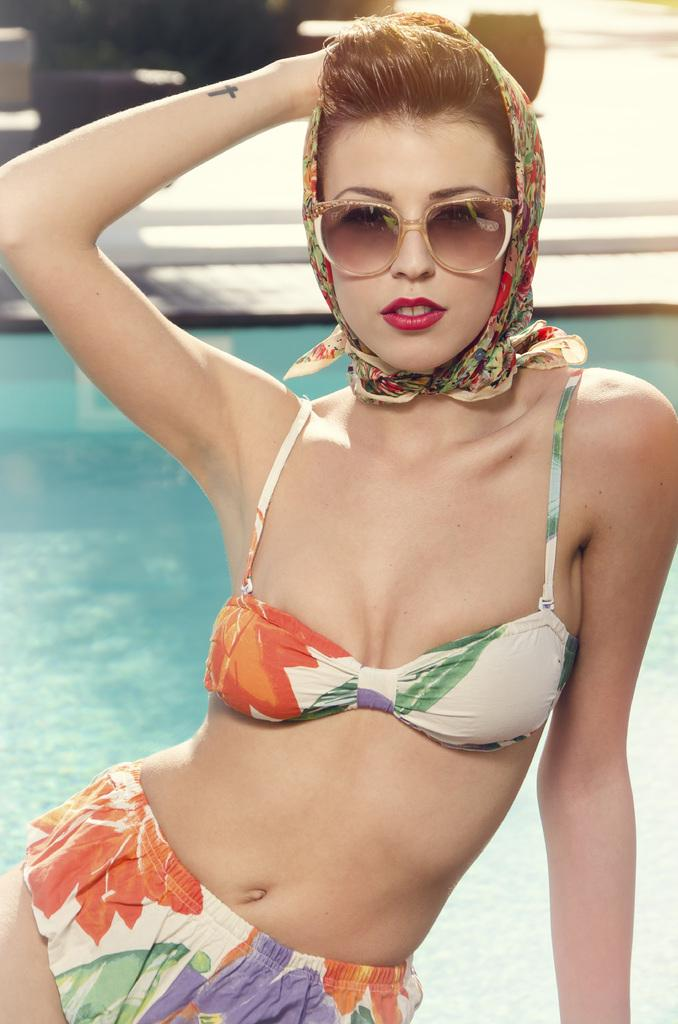Who is present in the image? There is a woman in the image. What accessory is the woman wearing? The woman is wearing spectacles. What can be seen in the background of the image? There is a water pool visible in the image. What type of juice is being served on the canvas in the image? There is no canvas or juice present in the image; it features a woman wearing spectacles and a water pool in the background. 